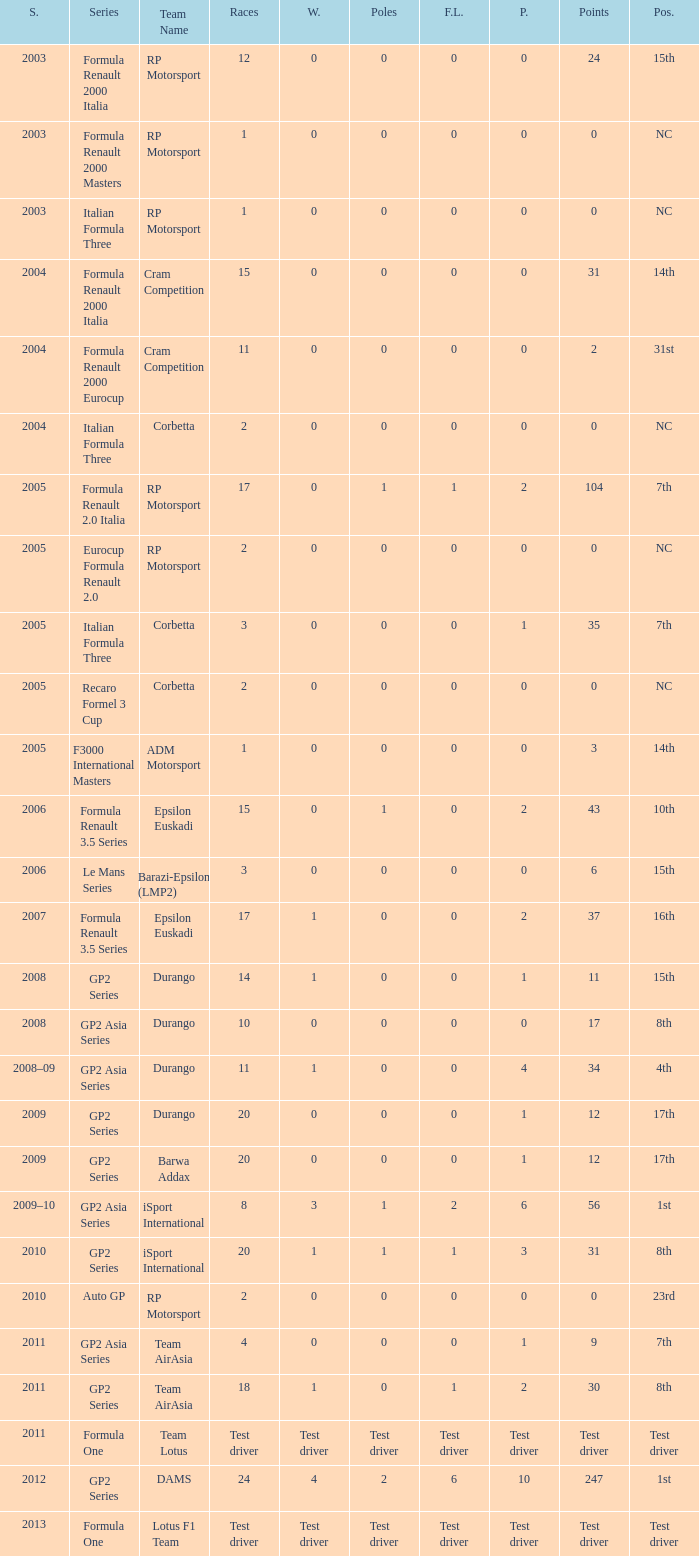What races have gp2 series, 0 F.L. and a 17th position? 20, 20. 